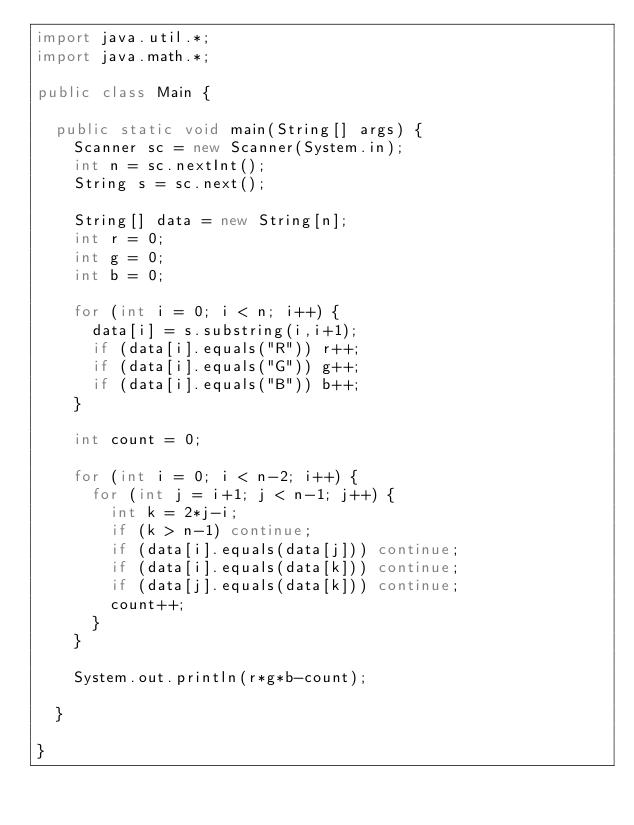<code> <loc_0><loc_0><loc_500><loc_500><_Java_>import java.util.*;
import java.math.*;

public class Main {

  public static void main(String[] args) {
    Scanner sc = new Scanner(System.in);
    int n = sc.nextInt();
    String s = sc.next();

    String[] data = new String[n];
    int r = 0;
    int g = 0;
    int b = 0;

    for (int i = 0; i < n; i++) {
      data[i] = s.substring(i,i+1);
      if (data[i].equals("R")) r++;
      if (data[i].equals("G")) g++;
      if (data[i].equals("B")) b++;
    }

    int count = 0;

    for (int i = 0; i < n-2; i++) {
      for (int j = i+1; j < n-1; j++) {
        int k = 2*j-i;
        if (k > n-1) continue;
        if (data[i].equals(data[j])) continue;
        if (data[i].equals(data[k])) continue;
        if (data[j].equals(data[k])) continue;
        count++;
      }
    }

    System.out.println(r*g*b-count);

  }

}
</code> 